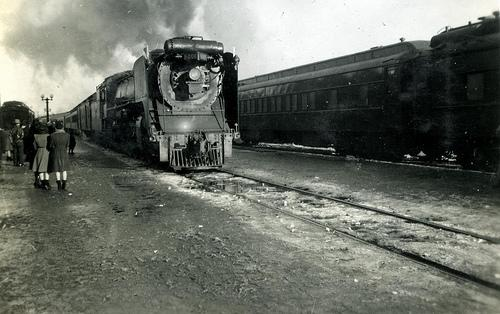Question: when was this picture taken?
Choices:
A. Daytime.
B. Lunchtime.
C. 8:00 am.
D. 10:00 am.
Answer with the letter. Answer: A Question: how is the weather?
Choices:
A. Sweltering.
B. Frigid.
C. Foggy.
D. Overcast.
Answer with the letter. Answer: D Question: who is in the picture?
Choices:
A. One woman.
B. Two men.
C. Two kids.
D. Two women.
Answer with the letter. Answer: D Question: where is this picture taken?
Choices:
A. A classroom.
B. A bathroom.
C. Train station.
D. A closet.
Answer with the letter. Answer: C 